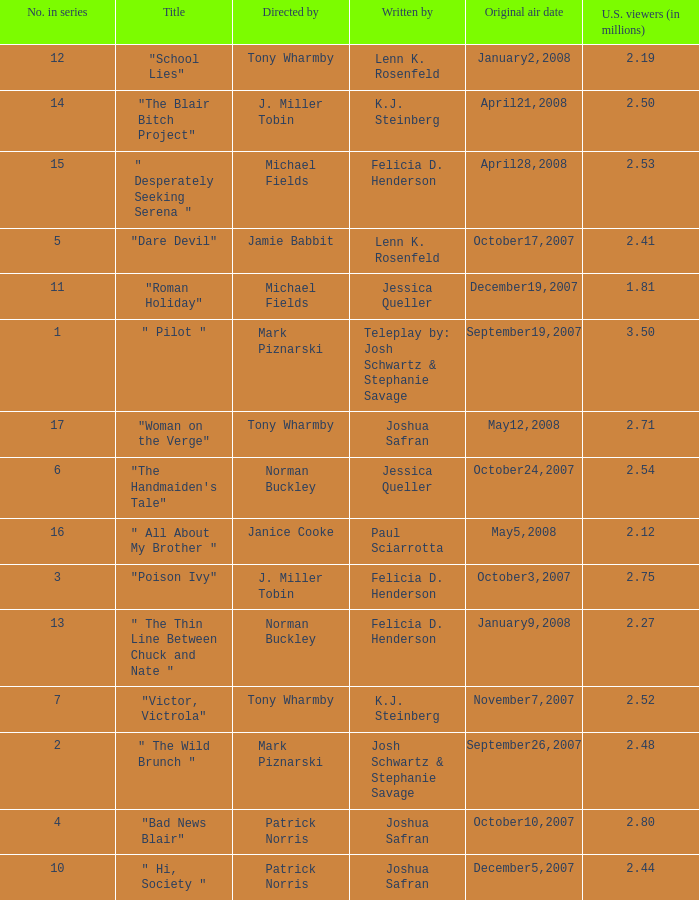What is the original air date when "poison ivy" is the title? October3,2007. 